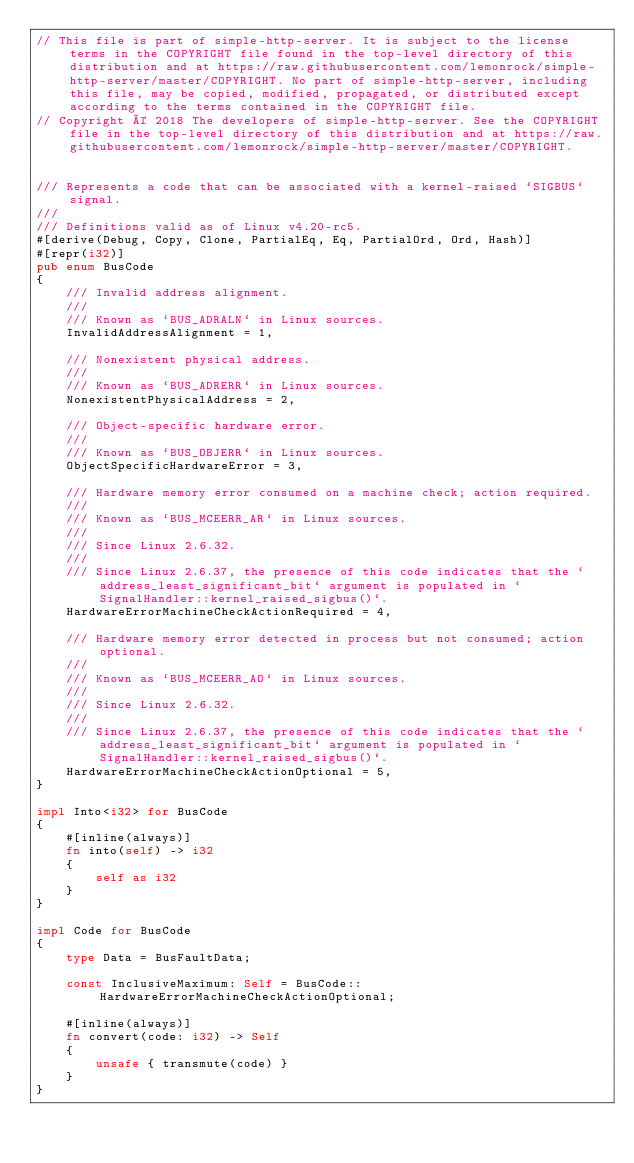<code> <loc_0><loc_0><loc_500><loc_500><_Rust_>// This file is part of simple-http-server. It is subject to the license terms in the COPYRIGHT file found in the top-level directory of this distribution and at https://raw.githubusercontent.com/lemonrock/simple-http-server/master/COPYRIGHT. No part of simple-http-server, including this file, may be copied, modified, propagated, or distributed except according to the terms contained in the COPYRIGHT file.
// Copyright © 2018 The developers of simple-http-server. See the COPYRIGHT file in the top-level directory of this distribution and at https://raw.githubusercontent.com/lemonrock/simple-http-server/master/COPYRIGHT.


/// Represents a code that can be associated with a kernel-raised `SIGBUS` signal.
///
/// Definitions valid as of Linux v4.20-rc5.
#[derive(Debug, Copy, Clone, PartialEq, Eq, PartialOrd, Ord, Hash)]
#[repr(i32)]
pub enum BusCode
{
	/// Invalid address alignment.
	///
	/// Known as `BUS_ADRALN` in Linux sources.
	InvalidAddressAlignment = 1,

	/// Nonexistent physical address.
	///
	/// Known as `BUS_ADRERR` in Linux sources.
	NonexistentPhysicalAddress = 2,

	/// Object-specific hardware error.
	///
	/// Known as `BUS_OBJERR` in Linux sources.
	ObjectSpecificHardwareError = 3,

	/// Hardware memory error consumed on a machine check; action required.
	///
	/// Known as `BUS_MCEERR_AR` in Linux sources.
	///
	/// Since Linux 2.6.32.
	///
	/// Since Linux 2.6.37, the presence of this code indicates that the `address_least_significant_bit` argument is populated in `SignalHandler::kernel_raised_sigbus()`.
	HardwareErrorMachineCheckActionRequired = 4,

	/// Hardware memory error detected in process but not consumed; action optional.
	///
	/// Known as `BUS_MCEERR_AO` in Linux sources.
	///
	/// Since Linux 2.6.32.
	///
	/// Since Linux 2.6.37, the presence of this code indicates that the `address_least_significant_bit` argument is populated in `SignalHandler::kernel_raised_sigbus()`.
	HardwareErrorMachineCheckActionOptional = 5,
}

impl Into<i32> for BusCode
{
	#[inline(always)]
	fn into(self) -> i32
	{
		self as i32
	}
}

impl Code for BusCode
{
	type Data = BusFaultData;

	const InclusiveMaximum: Self = BusCode::HardwareErrorMachineCheckActionOptional;

	#[inline(always)]
	fn convert(code: i32) -> Self
	{
		unsafe { transmute(code) }
	}
}
</code> 